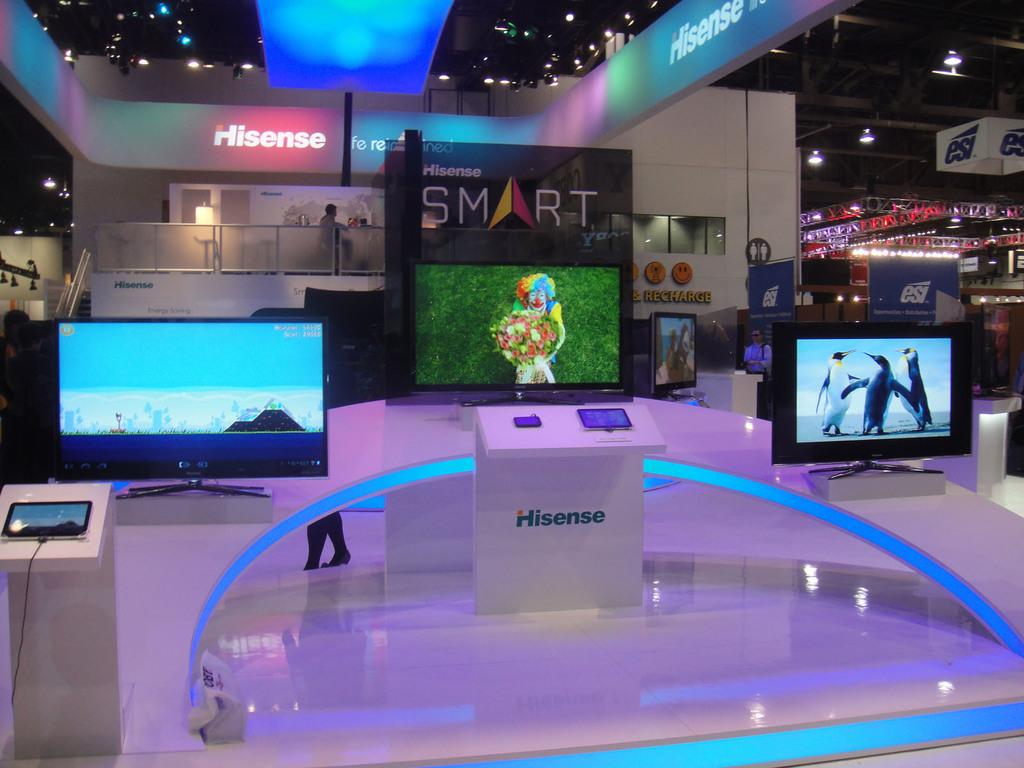<image>
Describe the image concisely. Three smart hisense branded televisions are displayed next to each other. 